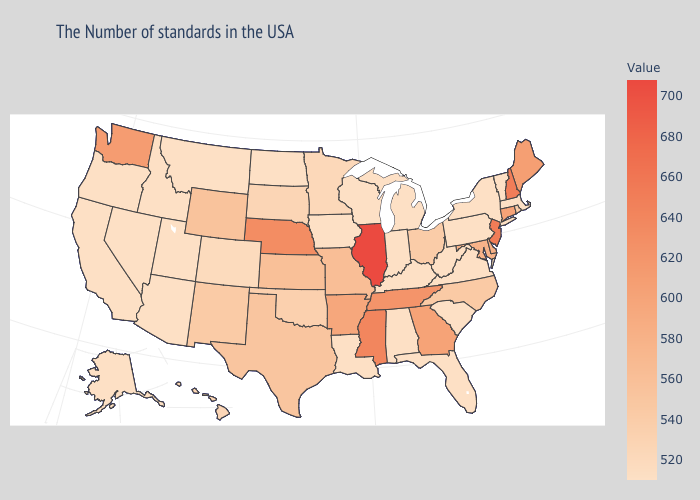Among the states that border Ohio , which have the highest value?
Give a very brief answer. Pennsylvania, West Virginia, Michigan, Kentucky, Indiana. Does Michigan have the lowest value in the USA?
Short answer required. Yes. Does Arkansas have the highest value in the South?
Short answer required. No. Which states have the lowest value in the USA?
Be succinct. Massachusetts, Vermont, New York, Pennsylvania, Virginia, South Carolina, West Virginia, Florida, Michigan, Kentucky, Indiana, Alabama, Wisconsin, Louisiana, Iowa, North Dakota, Utah, Montana, Arizona, Idaho, Nevada, California, Oregon, Alaska. Among the states that border Louisiana , which have the highest value?
Answer briefly. Mississippi. 